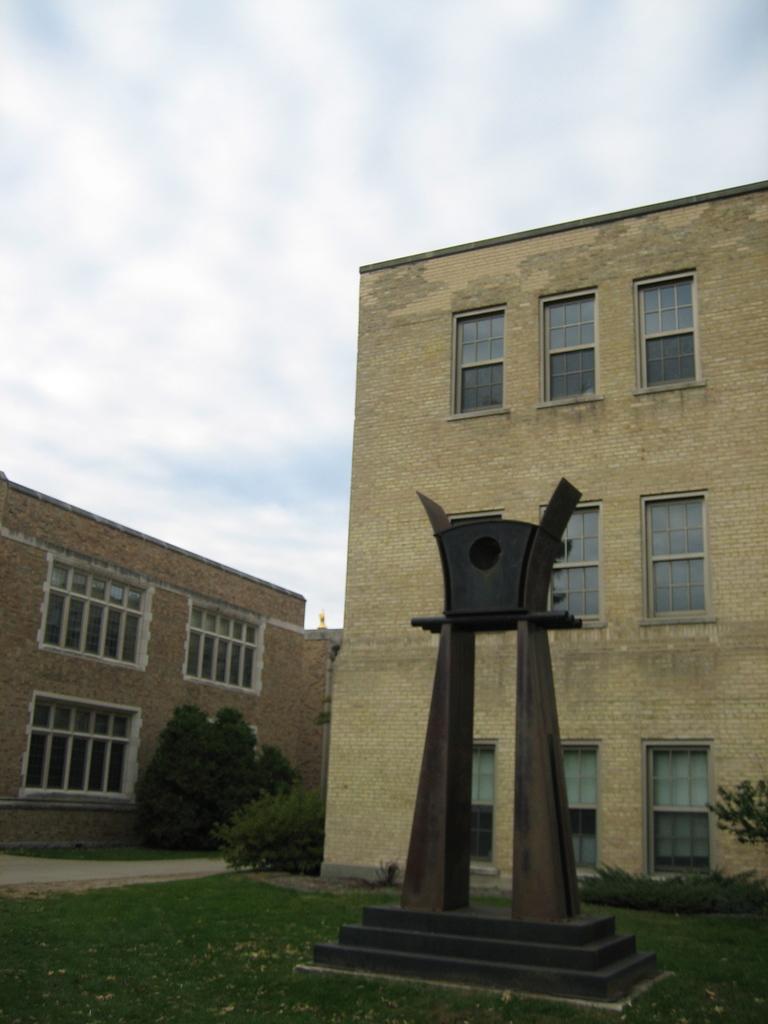In one or two sentences, can you explain what this image depicts? In this image we can see a sculpture and there are buildings. We can see trees. At the bottom there is grass. In the background there is sky. 